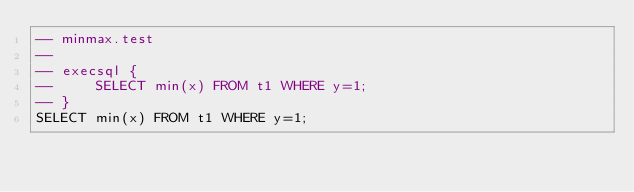Convert code to text. <code><loc_0><loc_0><loc_500><loc_500><_SQL_>-- minmax.test
-- 
-- execsql {
--     SELECT min(x) FROM t1 WHERE y=1;
-- }
SELECT min(x) FROM t1 WHERE y=1;</code> 